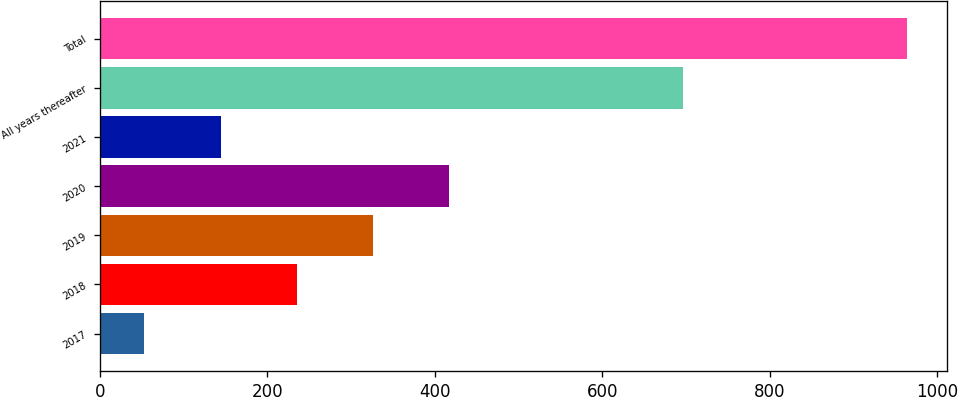Convert chart to OTSL. <chart><loc_0><loc_0><loc_500><loc_500><bar_chart><fcel>2017<fcel>2018<fcel>2019<fcel>2020<fcel>2021<fcel>All years thereafter<fcel>Total<nl><fcel>53<fcel>235.2<fcel>326.3<fcel>417.4<fcel>144.1<fcel>696<fcel>964<nl></chart> 